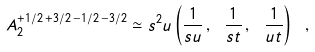<formula> <loc_0><loc_0><loc_500><loc_500>A _ { 2 } ^ { + 1 / 2 \, + 3 / 2 \, - 1 / 2 \, - 3 / 2 } \simeq s ^ { 2 } u \left ( \frac { 1 } { s u } \, , \ \frac { 1 } { s t } \, , \ \frac { 1 } { u t } \right ) \ ,</formula> 